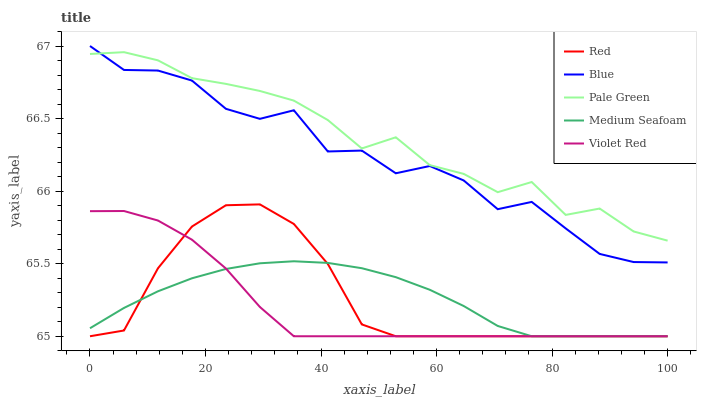Does Violet Red have the minimum area under the curve?
Answer yes or no. Yes. Does Pale Green have the maximum area under the curve?
Answer yes or no. Yes. Does Pale Green have the minimum area under the curve?
Answer yes or no. No. Does Violet Red have the maximum area under the curve?
Answer yes or no. No. Is Medium Seafoam the smoothest?
Answer yes or no. Yes. Is Blue the roughest?
Answer yes or no. Yes. Is Violet Red the smoothest?
Answer yes or no. No. Is Violet Red the roughest?
Answer yes or no. No. Does Violet Red have the lowest value?
Answer yes or no. Yes. Does Pale Green have the lowest value?
Answer yes or no. No. Does Blue have the highest value?
Answer yes or no. Yes. Does Violet Red have the highest value?
Answer yes or no. No. Is Violet Red less than Blue?
Answer yes or no. Yes. Is Pale Green greater than Red?
Answer yes or no. Yes. Does Pale Green intersect Blue?
Answer yes or no. Yes. Is Pale Green less than Blue?
Answer yes or no. No. Is Pale Green greater than Blue?
Answer yes or no. No. Does Violet Red intersect Blue?
Answer yes or no. No. 